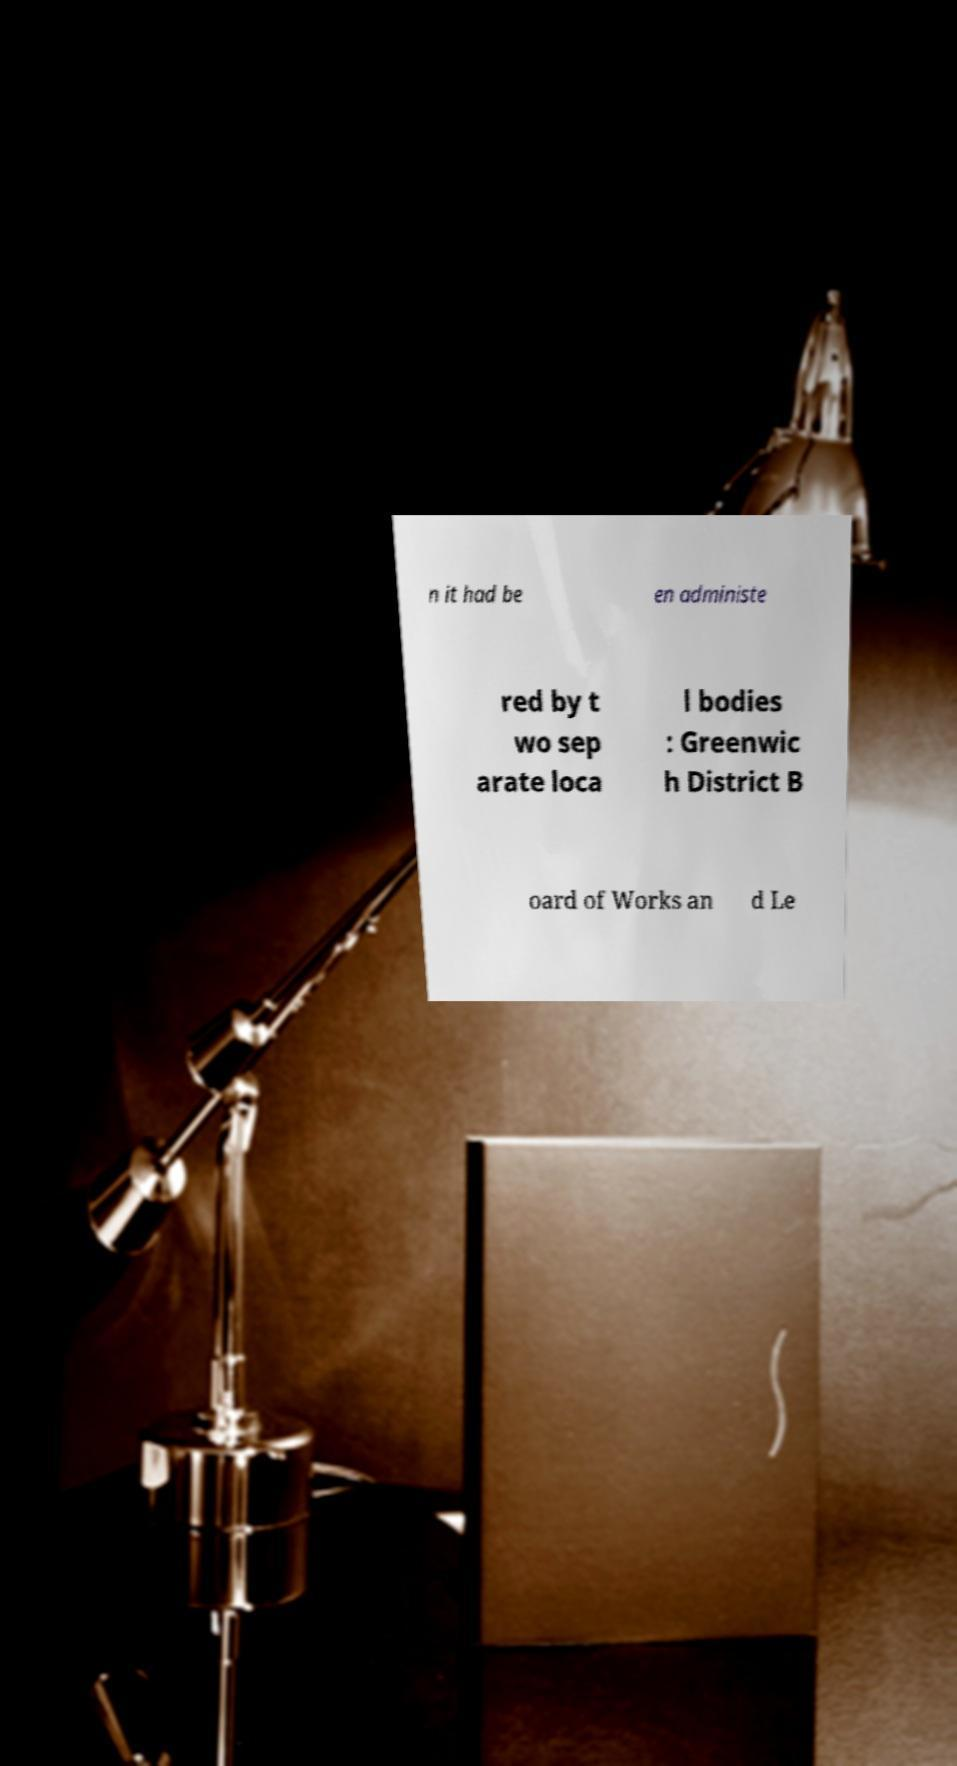Could you extract and type out the text from this image? n it had be en administe red by t wo sep arate loca l bodies : Greenwic h District B oard of Works an d Le 